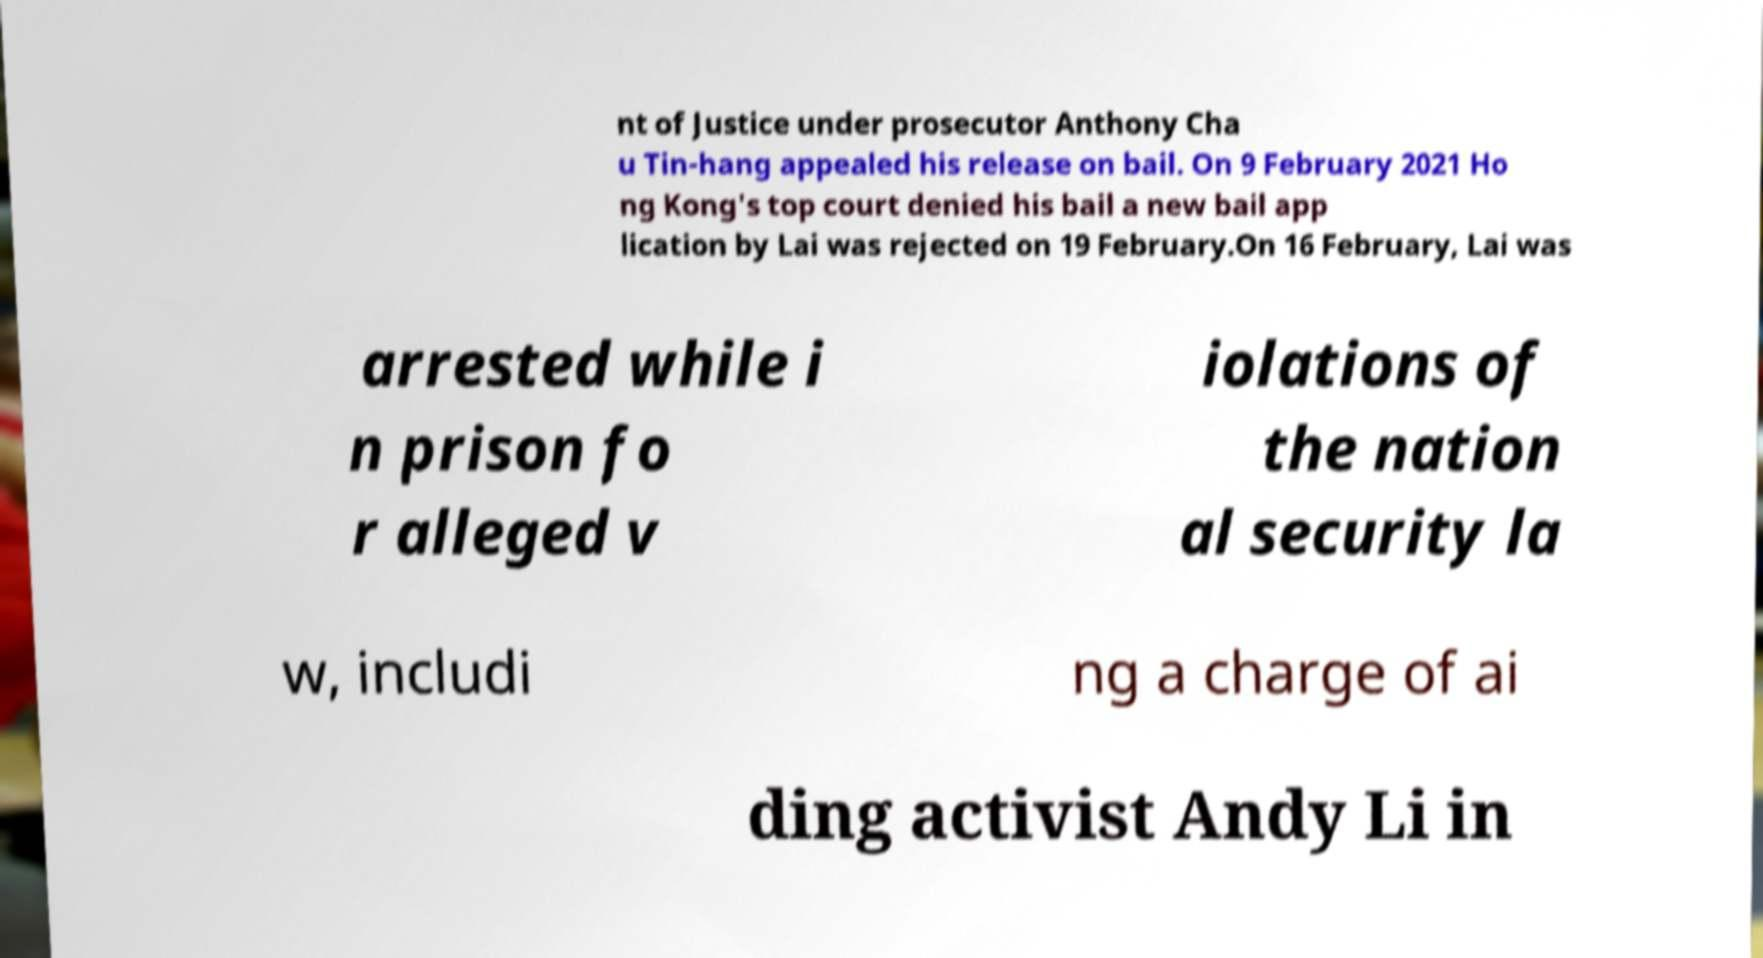Please read and relay the text visible in this image. What does it say? nt of Justice under prosecutor Anthony Cha u Tin-hang appealed his release on bail. On 9 February 2021 Ho ng Kong's top court denied his bail a new bail app lication by Lai was rejected on 19 February.On 16 February, Lai was arrested while i n prison fo r alleged v iolations of the nation al security la w, includi ng a charge of ai ding activist Andy Li in 